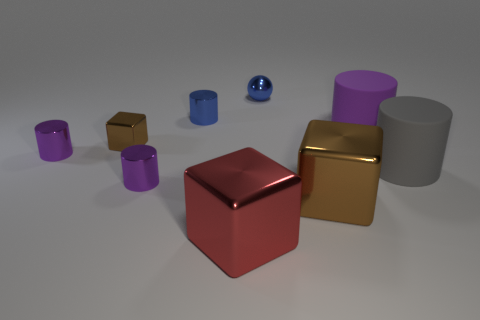Is there anything notable about the lighting or shadows in the scene? Yes, the lighting in the scene is diffused, coming from above, casting soft-edged shadows to the right of the objects. This creates a gentle contrast and enhances the perception of the objects' dimensions and the textures of their surfaces. The shadows and highlights suggest a calm, evenly lit environment, possibly set up to emphasize the objects' characteristics. 